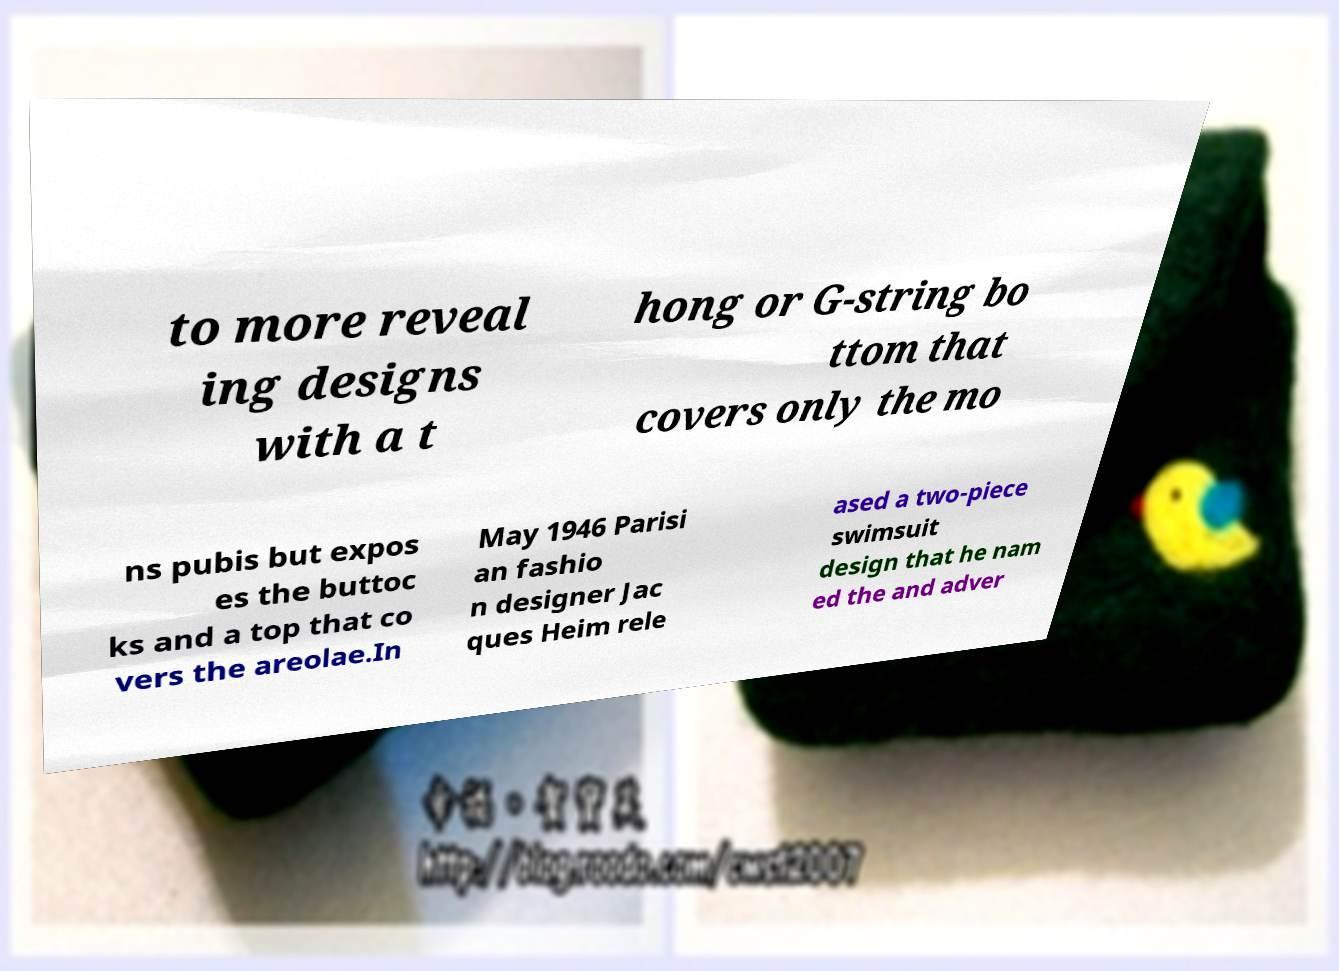Can you read and provide the text displayed in the image?This photo seems to have some interesting text. Can you extract and type it out for me? to more reveal ing designs with a t hong or G-string bo ttom that covers only the mo ns pubis but expos es the buttoc ks and a top that co vers the areolae.In May 1946 Parisi an fashio n designer Jac ques Heim rele ased a two-piece swimsuit design that he nam ed the and adver 